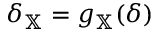<formula> <loc_0><loc_0><loc_500><loc_500>\delta _ { \mathbb { X } } = g _ { \mathbb { X } } ( \delta )</formula> 